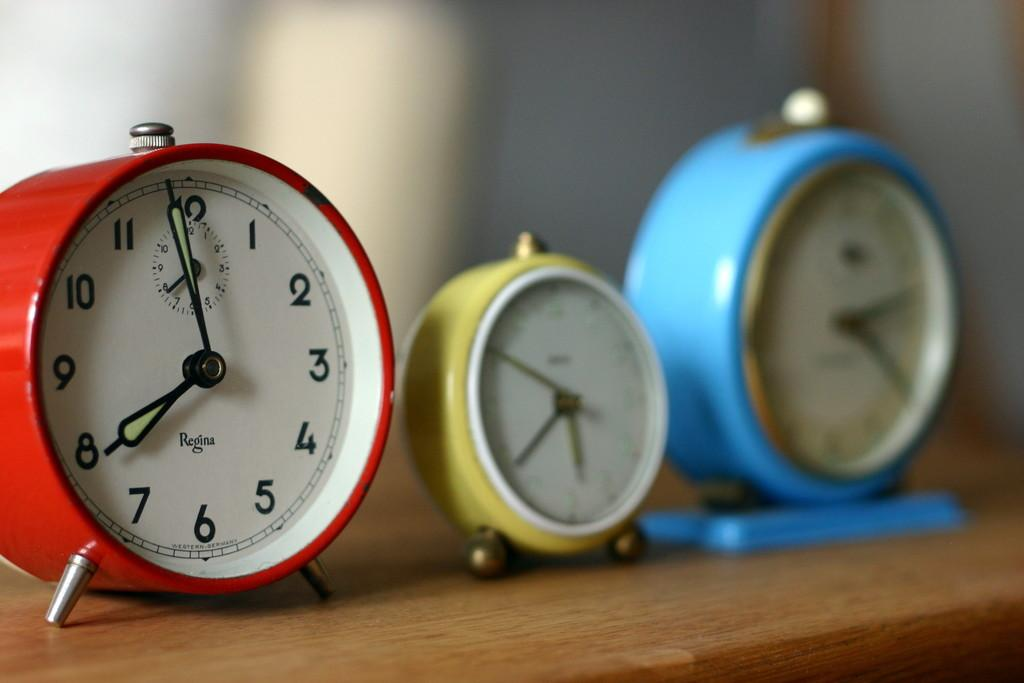<image>
Render a clear and concise summary of the photo. Three colorful analog clocks where the red one is made by Regina and set to 8:00 